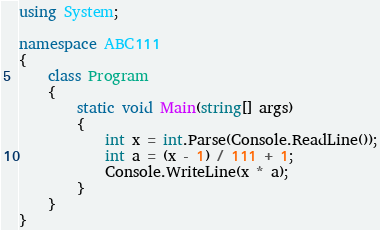<code> <loc_0><loc_0><loc_500><loc_500><_C#_>using System;

namespace ABC111
{
    class Program
    {
        static void Main(string[] args)
        {
            int x = int.Parse(Console.ReadLine());
            int a = (x - 1) / 111 + 1;
            Console.WriteLine(x * a);
        }
    }
}
</code> 